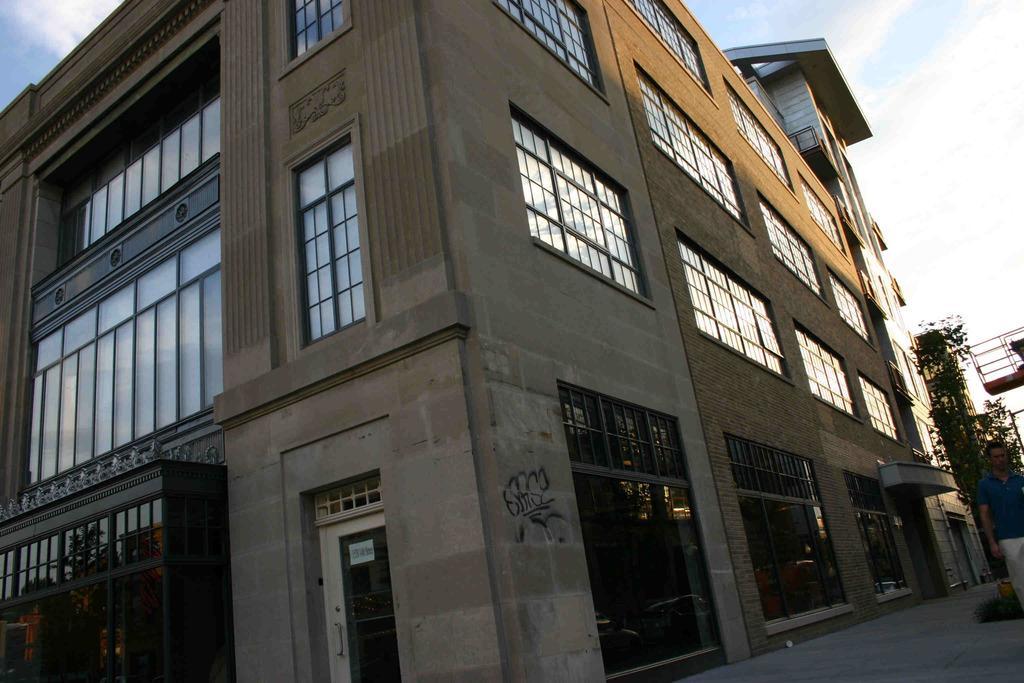Please provide a concise description of this image. In the foreground of the image we can see a building. To the right side of the image we can see a person standing on the path. In the background we can see plant and sky. 